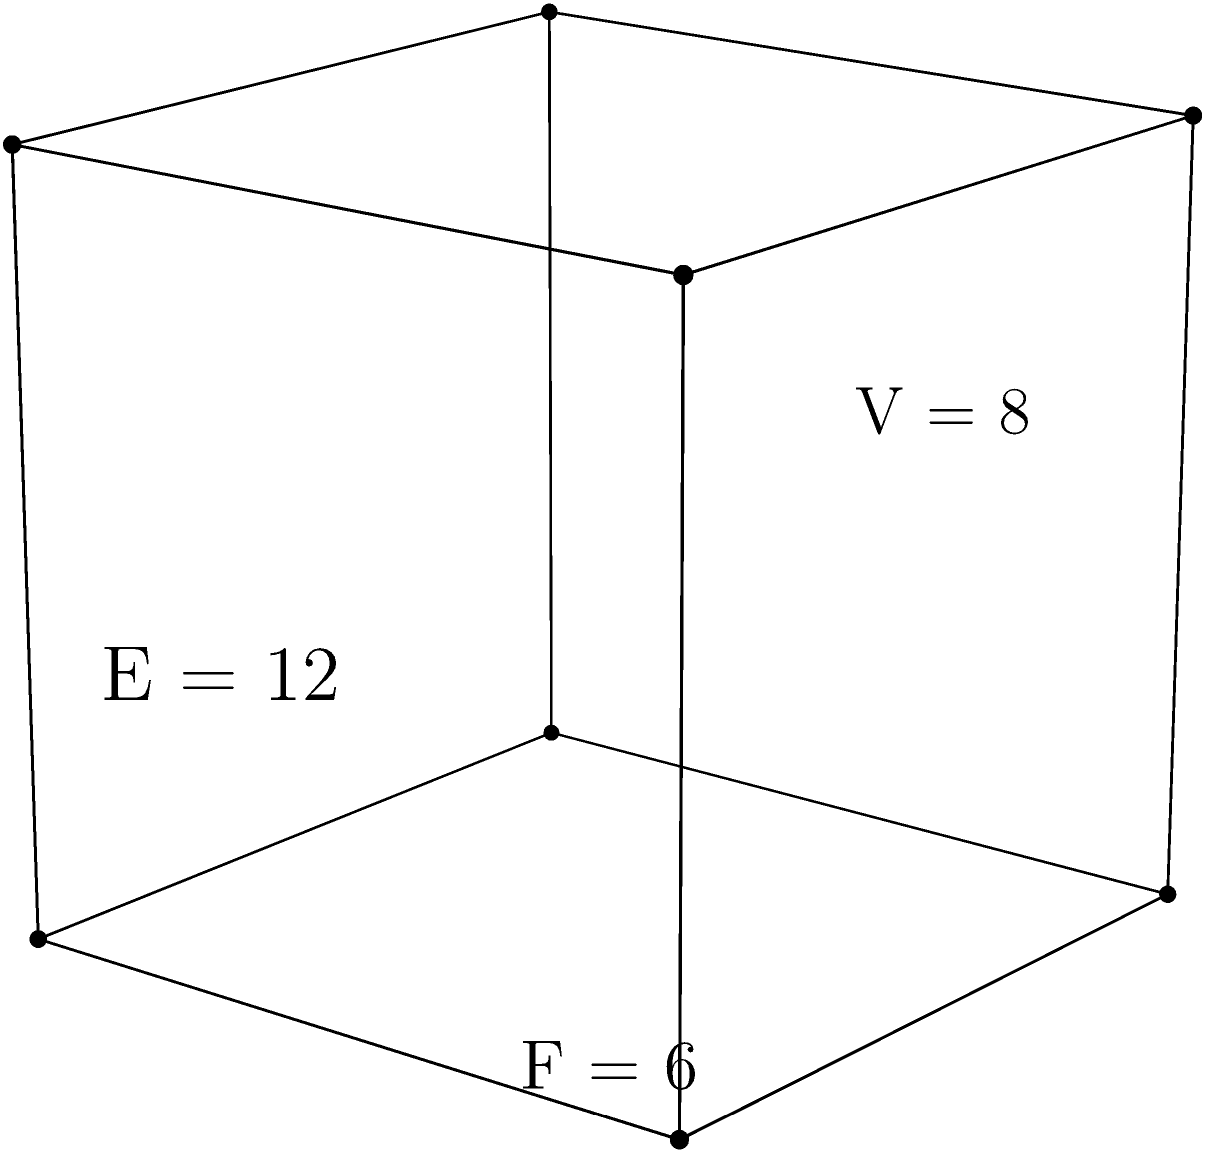In your latest podcast episode about solid geometry, you're discussing Euler's formula for polyhedra. Given the cube shown in the diagram, how would you verify Euler's formula ($V - E + F = 2$) and explain its significance in understanding the relationships between faces, edges, and vertices in polyhedra? To verify Euler's formula for the cube and explain its significance, let's follow these steps:

1. Count the elements of the cube:
   - Vertices (V): 8
   - Edges (E): 12
   - Faces (F): 6

2. Apply Euler's formula:
   $V - E + F = 2$
   $8 - 12 + 6 = 2$
   $2 = 2$

   The equation holds true for the cube, verifying Euler's formula.

3. Significance of Euler's formula:
   a) Universality: This formula applies to all convex polyhedra and even some non-convex polyhedra.
   b) Topological invariant: The result (2) is constant regardless of the polyhedron's shape or size.
   c) Relationships between elements: It shows how changes in one element affect others. For example, adding a face typically requires adding edges and vertices to maintain the equation.
   d) Foundation for further study: Euler's formula is crucial in more advanced topics like graph theory and topology.

4. Exploring other polyhedra:
   - Tetrahedron: V = 4, E = 6, F = 4
     $4 - 6 + 4 = 2$
   - Octahedron: V = 6, E = 12, F = 8
     $6 - 12 + 8 = 2$
   - Dodecahedron: V = 20, E = 30, F = 12
     $20 - 30 + 12 = 2$

   These examples further demonstrate the formula's consistency across different polyhedra.

5. Limitations and extensions:
   - The formula doesn't work for polyhedra with holes (like a torus).
   - For polyhedra with g holes, the extended formula is $V - E + F = 2 - 2g$.

Understanding Euler's formula provides insight into the fundamental structure of polyhedra and serves as a stepping stone to more complex geometric concepts.
Answer: Euler's formula ($V - E + F = 2$) holds true for the cube (8 - 12 + 6 = 2), demonstrating the consistent relationship between vertices, edges, and faces in polyhedra. 